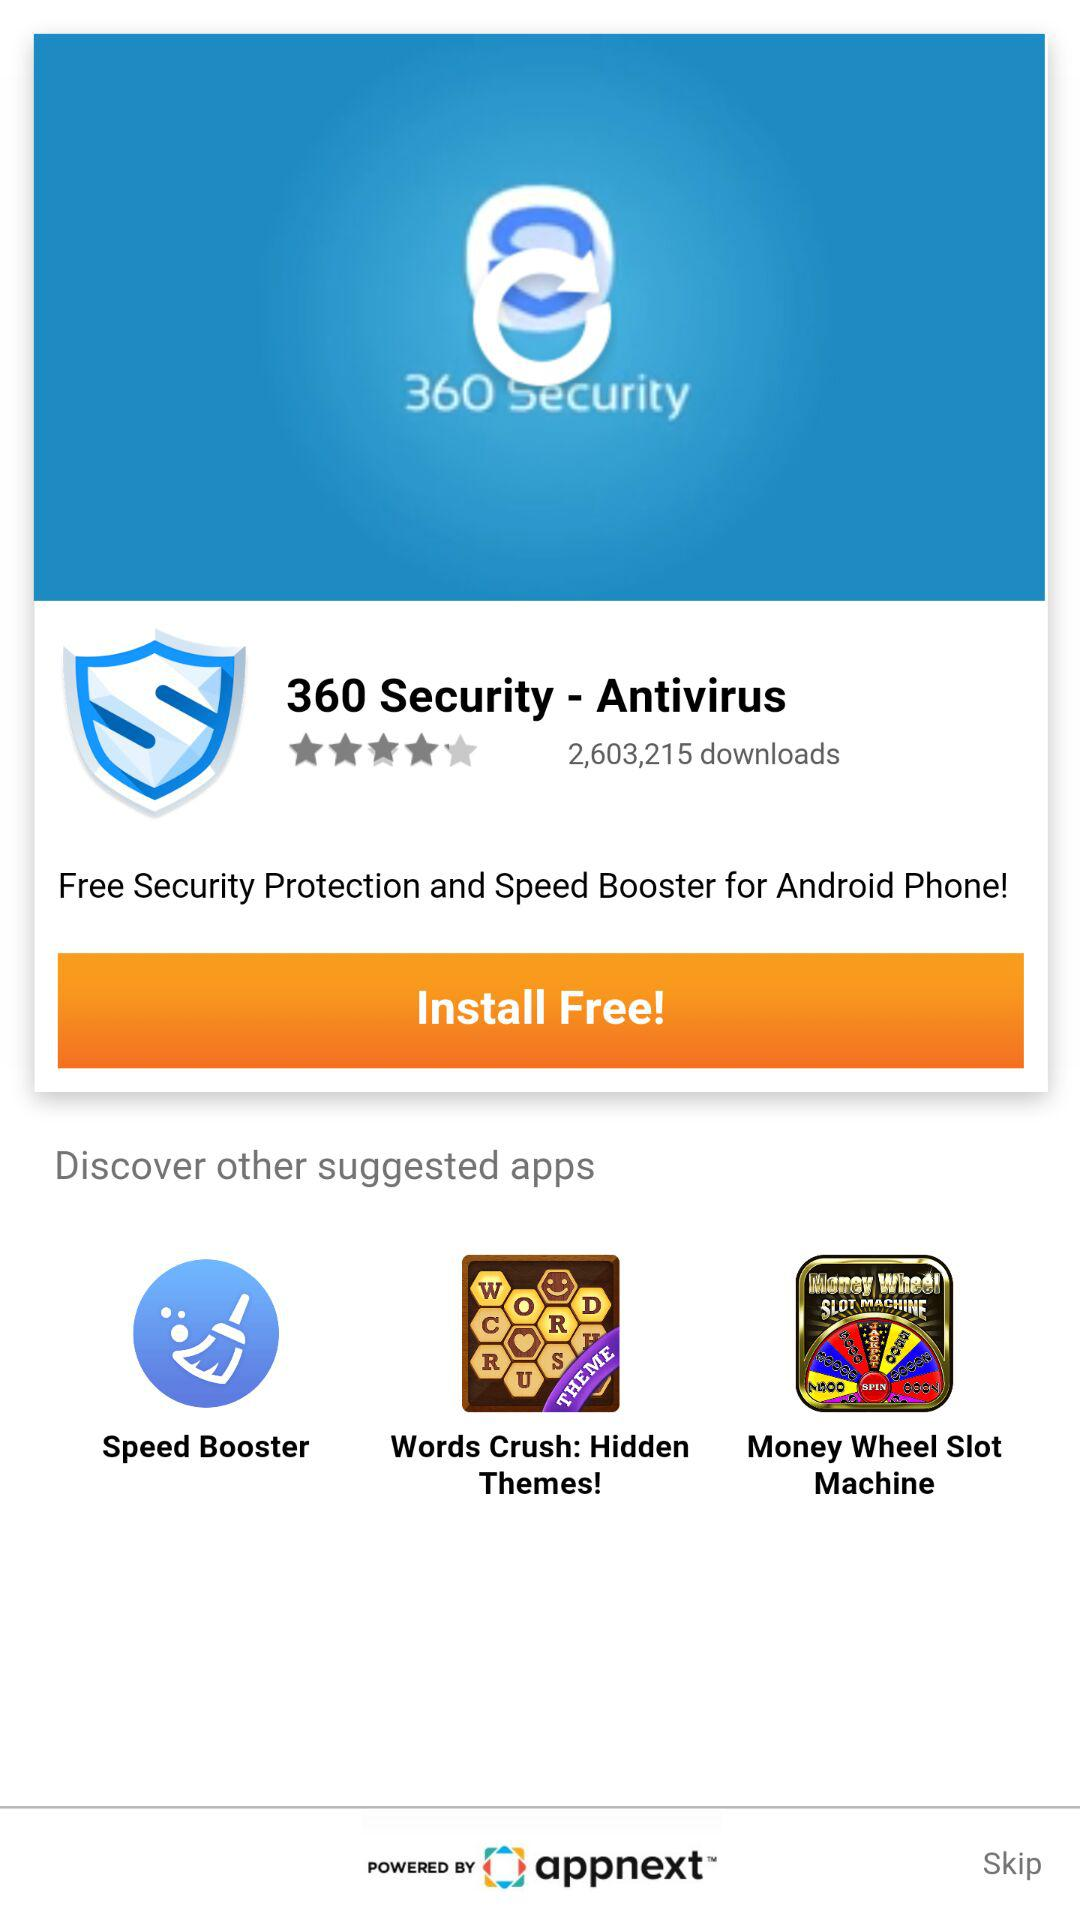What is the name of the application? The name of the application is "360 Security - Antivirus". 